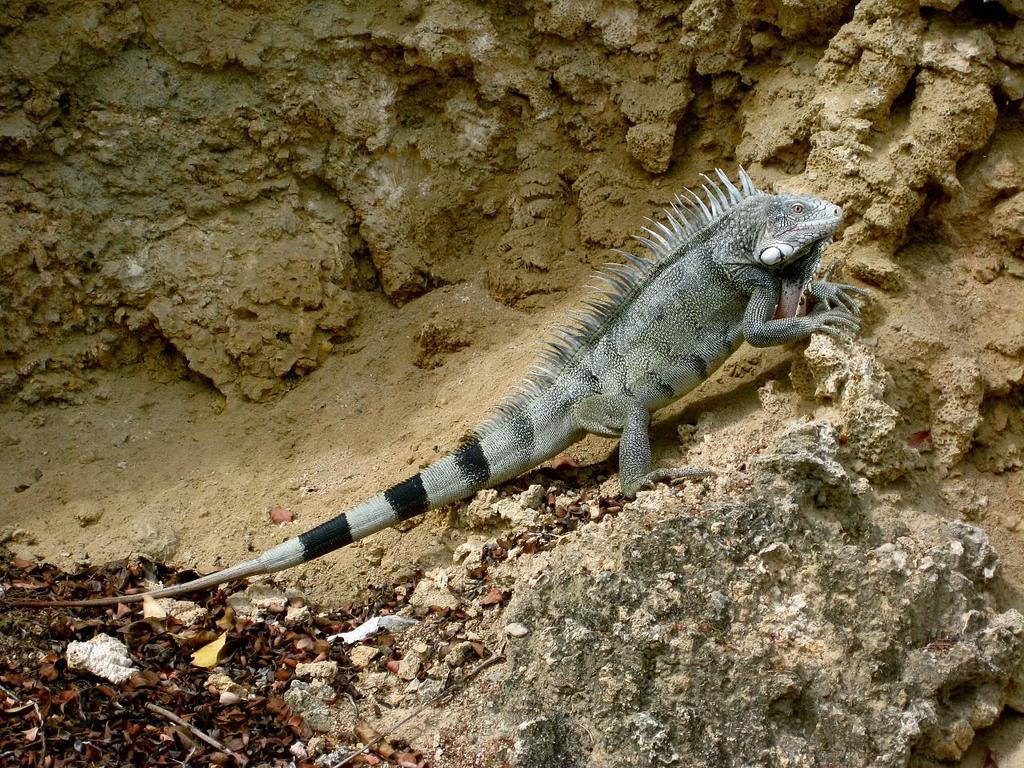What type of animal is in the picture? There is an iguana in the picture. What is the iguana standing on? The iguana is standing on stones. What can be seen in the bottom left corner of the image? Leaves and sticks are visible in the bottom left corner of the image. What type of substance is the iguana using to drive in the image? There is no indication in the image that the iguana is driving or using any substance to do so. 